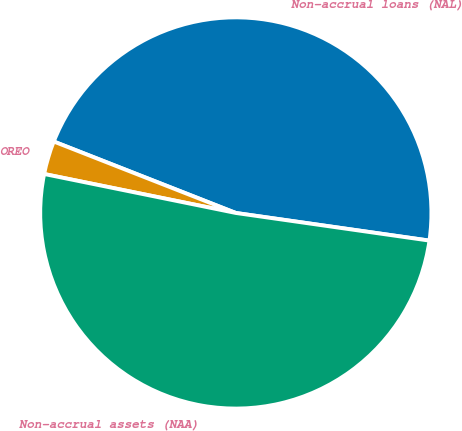Convert chart. <chart><loc_0><loc_0><loc_500><loc_500><pie_chart><fcel>Non-accrual loans (NAL)<fcel>OREO<fcel>Non-accrual assets (NAA)<nl><fcel>46.31%<fcel>2.76%<fcel>50.94%<nl></chart> 